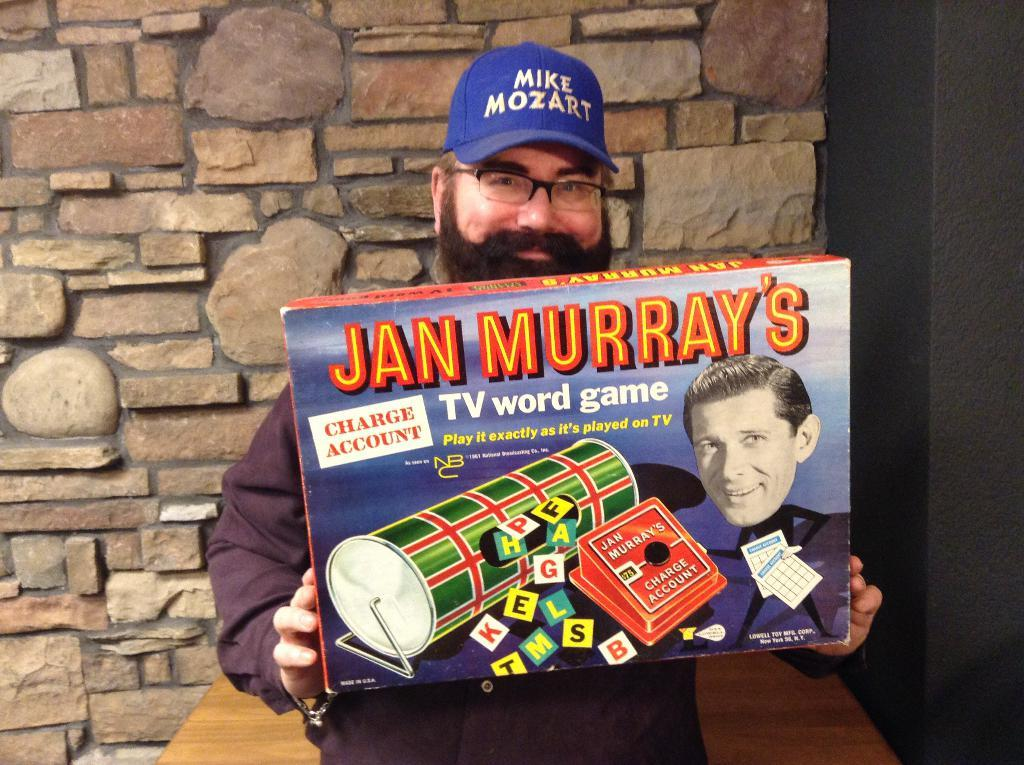Who is in the image? There is a man in the image. What is the man holding in the image? The man is holding a box. What can be seen on the man's head? The man is wearing a blue cap. What accessory is the man wearing on his face? The man is wearing spectacles. What piece of furniture is in the image? There is a table in the image. Where is the table located in relation to the wall? The table is in front of a wall. What type of plot is the man walking on in the image? There is no plot or walking depicted in the image; the man is standing and holding a box. 